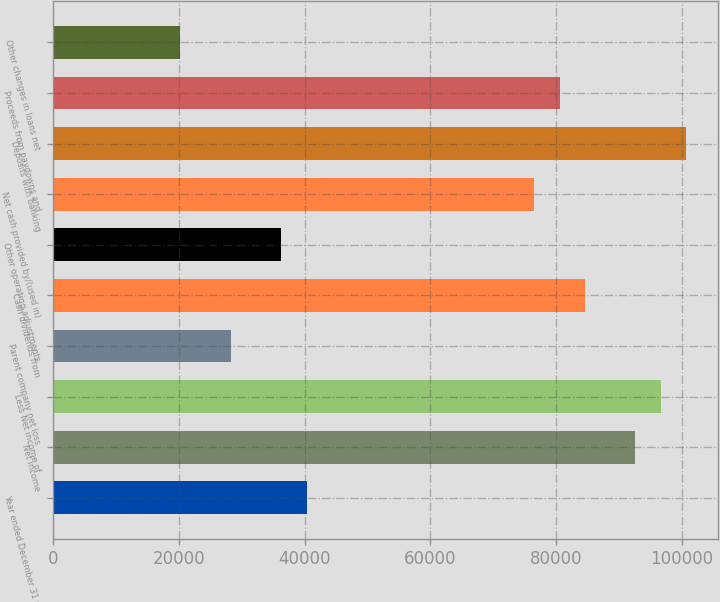Convert chart. <chart><loc_0><loc_0><loc_500><loc_500><bar_chart><fcel>Year ended December 31 (in<fcel>Net income<fcel>Less Net income of<fcel>Parent company net loss<fcel>Cash dividends from<fcel>Other operating adjustments<fcel>Net cash provided by/(used in)<fcel>Deposits with banking<fcel>Proceeds from paydowns and<fcel>Other changes in loans net<nl><fcel>40284<fcel>92611.6<fcel>96636.8<fcel>28208.4<fcel>84561.2<fcel>36258.8<fcel>76510.8<fcel>100662<fcel>80536<fcel>20158<nl></chart> 